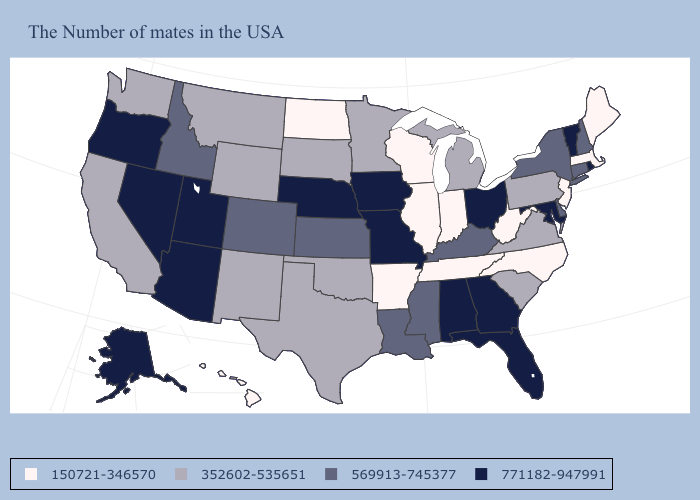Does New Jersey have the lowest value in the USA?
Write a very short answer. Yes. Which states hav the highest value in the Northeast?
Answer briefly. Rhode Island, Vermont. Name the states that have a value in the range 150721-346570?
Answer briefly. Maine, Massachusetts, New Jersey, North Carolina, West Virginia, Indiana, Tennessee, Wisconsin, Illinois, Arkansas, North Dakota, Hawaii. Name the states that have a value in the range 771182-947991?
Keep it brief. Rhode Island, Vermont, Maryland, Ohio, Florida, Georgia, Alabama, Missouri, Iowa, Nebraska, Utah, Arizona, Nevada, Oregon, Alaska. Does North Carolina have the lowest value in the South?
Give a very brief answer. Yes. What is the value of New York?
Write a very short answer. 569913-745377. What is the highest value in the Northeast ?
Answer briefly. 771182-947991. Among the states that border Texas , does Louisiana have the highest value?
Answer briefly. Yes. Which states have the highest value in the USA?
Concise answer only. Rhode Island, Vermont, Maryland, Ohio, Florida, Georgia, Alabama, Missouri, Iowa, Nebraska, Utah, Arizona, Nevada, Oregon, Alaska. What is the value of Mississippi?
Concise answer only. 569913-745377. Which states have the lowest value in the USA?
Be succinct. Maine, Massachusetts, New Jersey, North Carolina, West Virginia, Indiana, Tennessee, Wisconsin, Illinois, Arkansas, North Dakota, Hawaii. Does Nebraska have the highest value in the MidWest?
Write a very short answer. Yes. Does Montana have a higher value than Florida?
Be succinct. No. Which states have the lowest value in the West?
Write a very short answer. Hawaii. Among the states that border Rhode Island , does Massachusetts have the lowest value?
Quick response, please. Yes. 